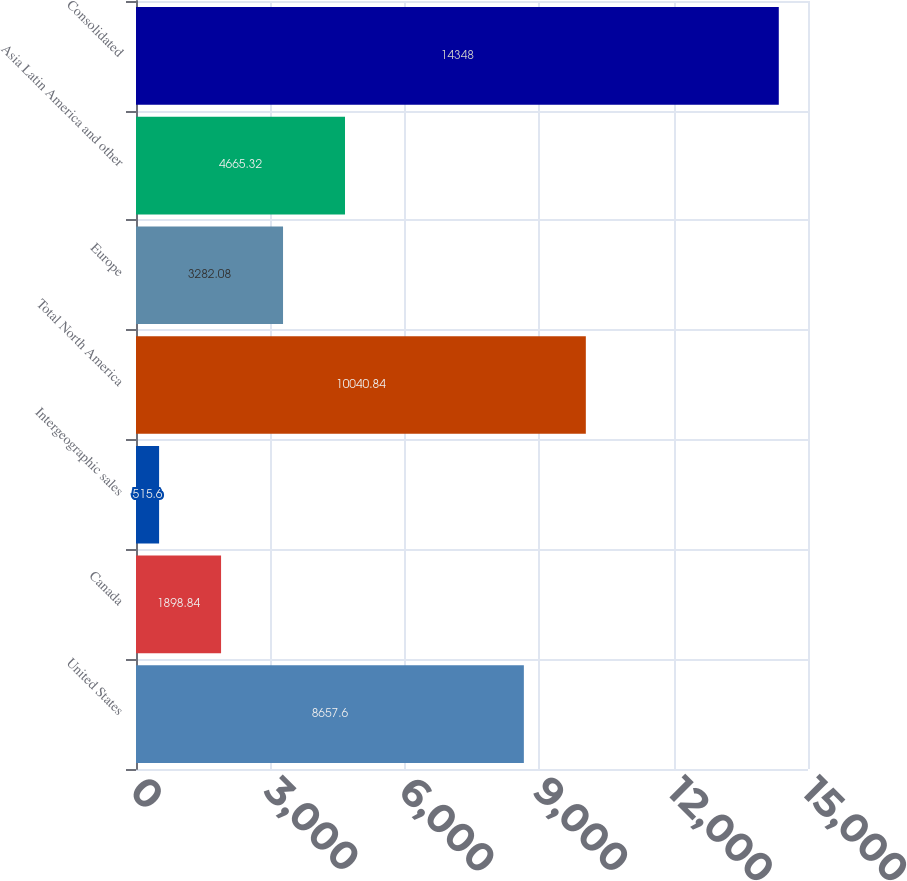Convert chart. <chart><loc_0><loc_0><loc_500><loc_500><bar_chart><fcel>United States<fcel>Canada<fcel>Intergeographic sales<fcel>Total North America<fcel>Europe<fcel>Asia Latin America and other<fcel>Consolidated<nl><fcel>8657.6<fcel>1898.84<fcel>515.6<fcel>10040.8<fcel>3282.08<fcel>4665.32<fcel>14348<nl></chart> 